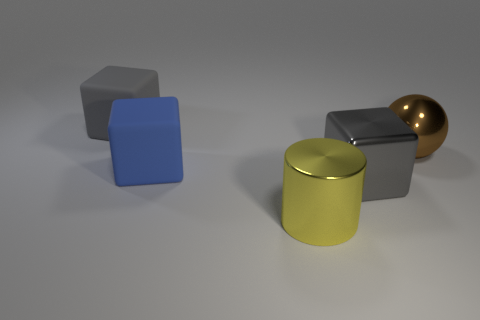What are the different shapes visible in the image? The image showcases a variety of geometric shapes including a large cylinder, a sphere, and several cuboids. 